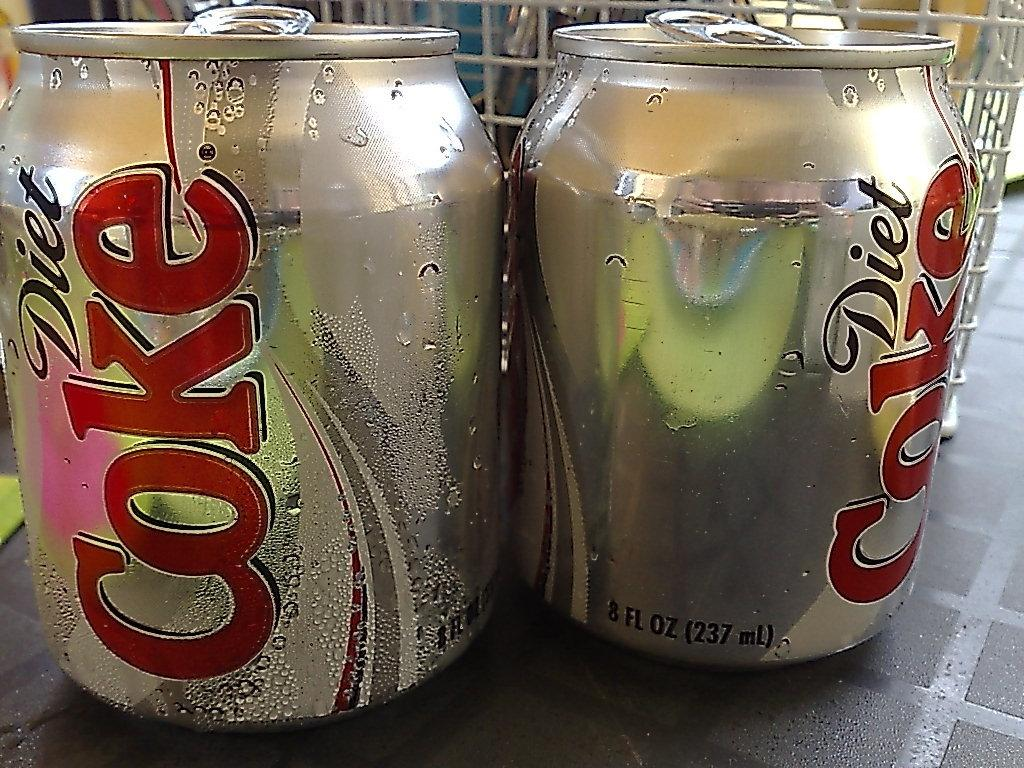<image>
Render a clear and concise summary of the photo. Two cans of Diet Coke sit on a counter. 